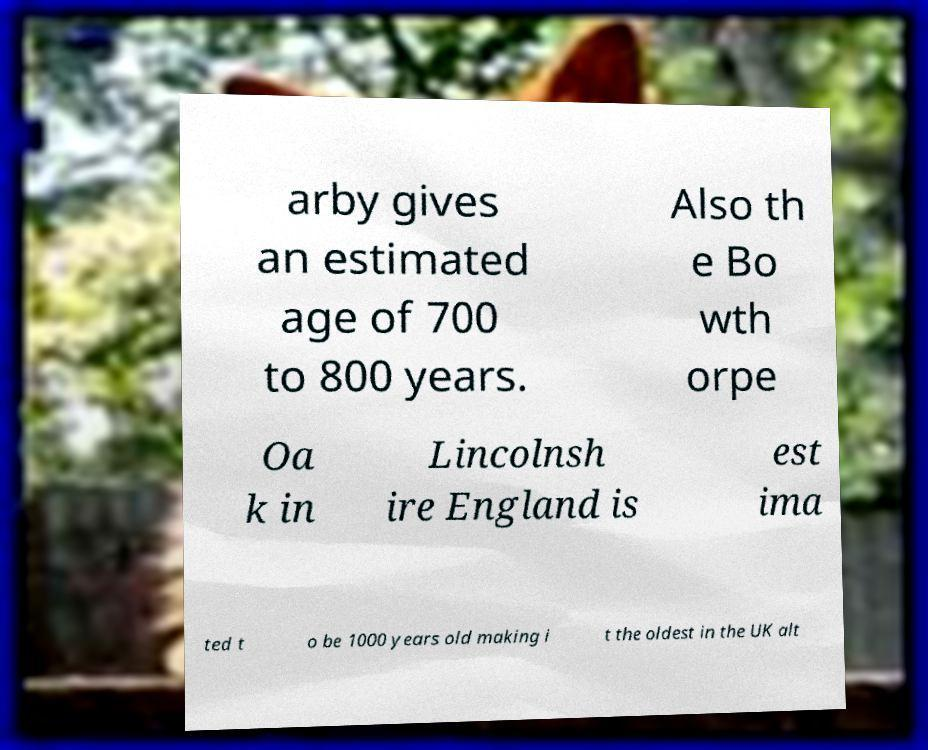Can you read and provide the text displayed in the image?This photo seems to have some interesting text. Can you extract and type it out for me? arby gives an estimated age of 700 to 800 years. Also th e Bo wth orpe Oa k in Lincolnsh ire England is est ima ted t o be 1000 years old making i t the oldest in the UK alt 